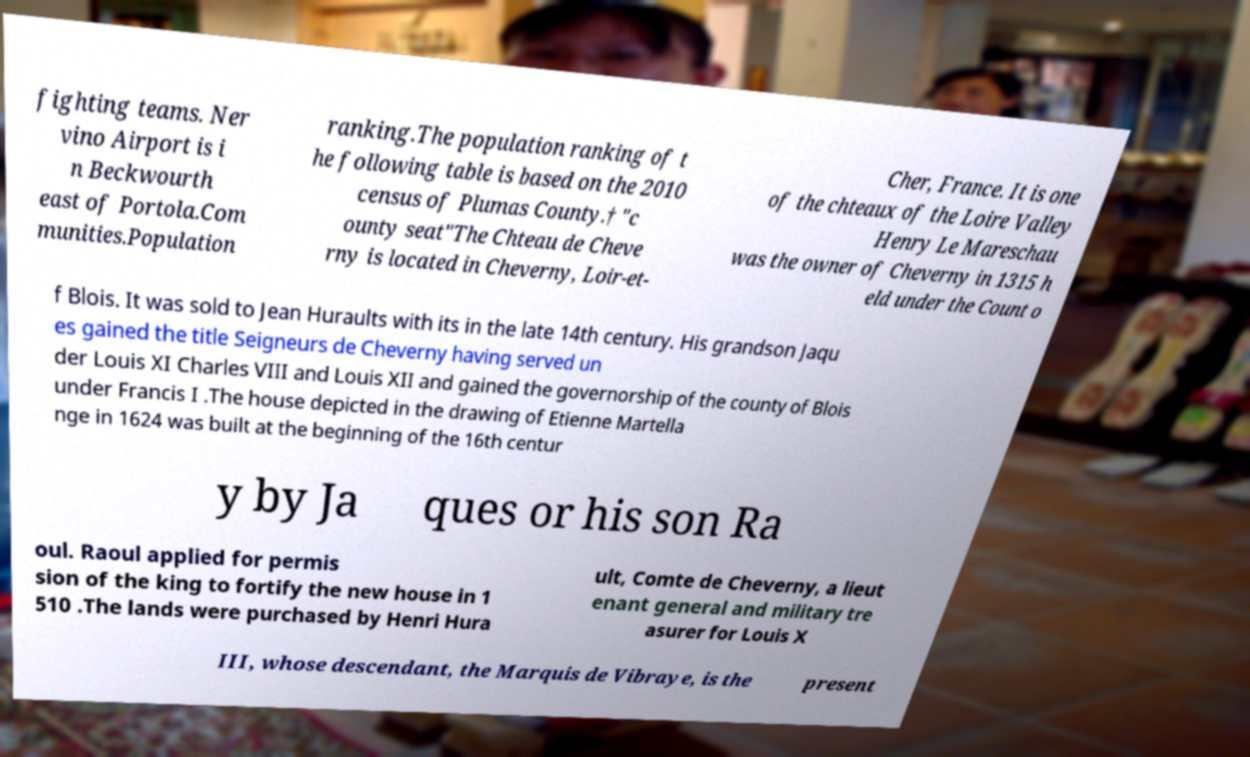I need the written content from this picture converted into text. Can you do that? fighting teams. Ner vino Airport is i n Beckwourth east of Portola.Com munities.Population ranking.The population ranking of t he following table is based on the 2010 census of Plumas County.† "c ounty seat"The Chteau de Cheve rny is located in Cheverny, Loir-et- Cher, France. It is one of the chteaux of the Loire Valley Henry Le Mareschau was the owner of Cheverny in 1315 h eld under the Count o f Blois. It was sold to Jean Huraults with its in the late 14th century. His grandson Jaqu es gained the title Seigneurs de Cheverny having served un der Louis XI Charles VIII and Louis XII and gained the governorship of the county of Blois under Francis I .The house depicted in the drawing of Etienne Martella nge in 1624 was built at the beginning of the 16th centur y by Ja ques or his son Ra oul. Raoul applied for permis sion of the king to fortify the new house in 1 510 .The lands were purchased by Henri Hura ult, Comte de Cheverny, a lieut enant general and military tre asurer for Louis X III, whose descendant, the Marquis de Vibraye, is the present 